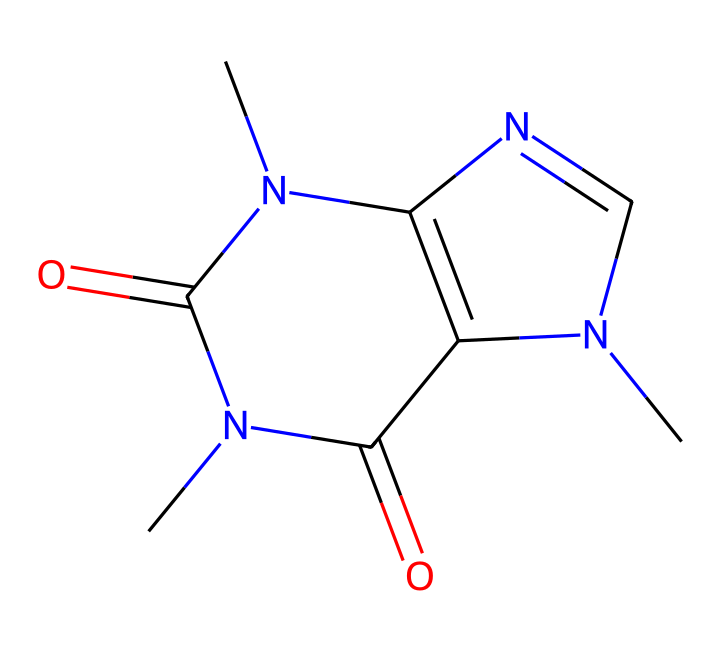what is the total number of nitrogen atoms in the caffeine molecule? Observing the SMILES representation, we see two nitrogen atoms (‘N’), indicating the presence of two nitrogen atoms in the structure.
Answer: two how many rings are present in the cage structure of caffeine? Analyzing the structure, it becomes apparent that there are two interconnected rings that form the cage-like structure of caffeine.
Answer: two what elements are present in the caffeine structure? The SMILES representation includes carbon (C), nitrogen (N), and oxygen (O) atoms, indicating that caffeine is composed of these three elements.
Answer: carbon, nitrogen, oxygen does this caffeine molecule contain any double bonds? By examining the SMILES notation, we can see that there are double bonds indicated by the equal sign (‘=’), confirming that this molecule has double bonds within its structure.
Answer: yes what type of compound is caffeine classified as based on its structure? Given the presence of the cage structure and nitrogen atoms, caffeine is classified as an alkaloid, which is a type of nitrogen-containing compound often found in plants.
Answer: alkaloid how many carbon atoms are there in the caffeine molecule? From the SMILES representation of caffeine, we can count a total of eight carbon atoms present in the structure, as denoted by the letters 'C'.
Answer: eight what is the molecular formula for caffeine based on the structure? Analyzing the elements and their counts from the SMILES representation, caffeine has 8 carbons, 10 hydrogens, 4 nitrogens, and 2 oxygens, leading to the molecular formula C8H10N4O2.
Answer: C8H10N4O2 